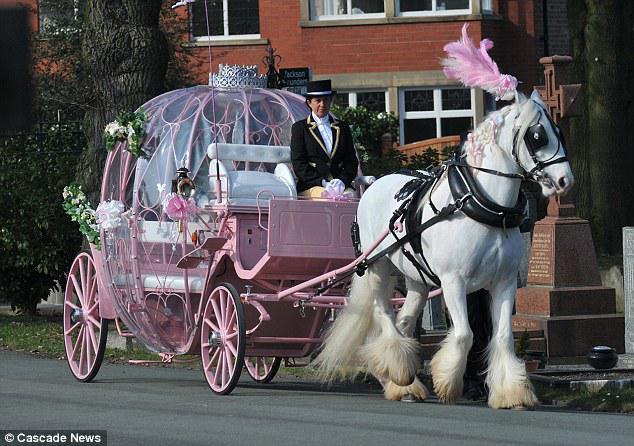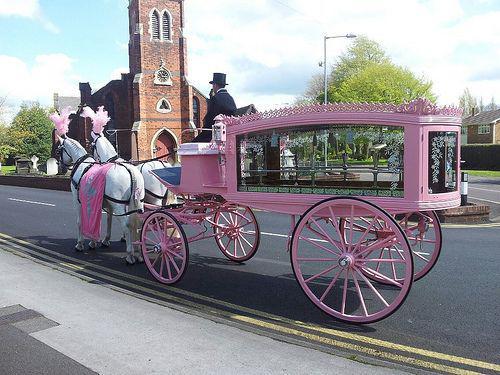The first image is the image on the left, the second image is the image on the right. Given the left and right images, does the statement "One of the carriages is pulled by a single horse." hold true? Answer yes or no. Yes. The first image is the image on the left, the second image is the image on the right. Examine the images to the left and right. Is the description "At least two horses in the image on the left have pink head dresses." accurate? Answer yes or no. No. 